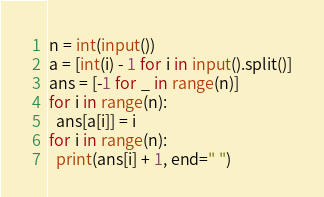<code> <loc_0><loc_0><loc_500><loc_500><_Python_>n = int(input())
a = [int(i) - 1 for i in input().split()]
ans = [-1 for _ in range(n)]
for i in range(n):
  ans[a[i]] = i
for i in range(n):
  print(ans[i] + 1, end=" ")</code> 